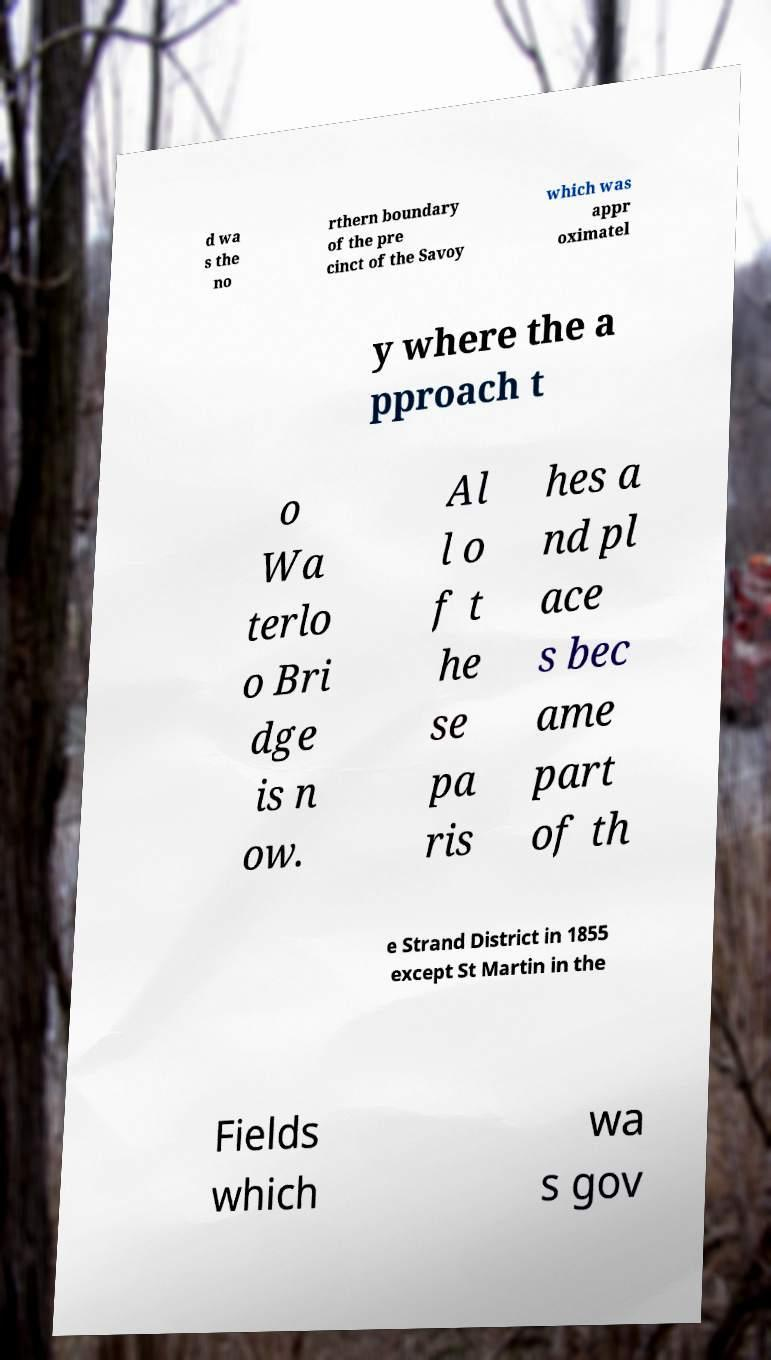Please read and relay the text visible in this image. What does it say? d wa s the no rthern boundary of the pre cinct of the Savoy which was appr oximatel y where the a pproach t o Wa terlo o Bri dge is n ow. Al l o f t he se pa ris hes a nd pl ace s bec ame part of th e Strand District in 1855 except St Martin in the Fields which wa s gov 